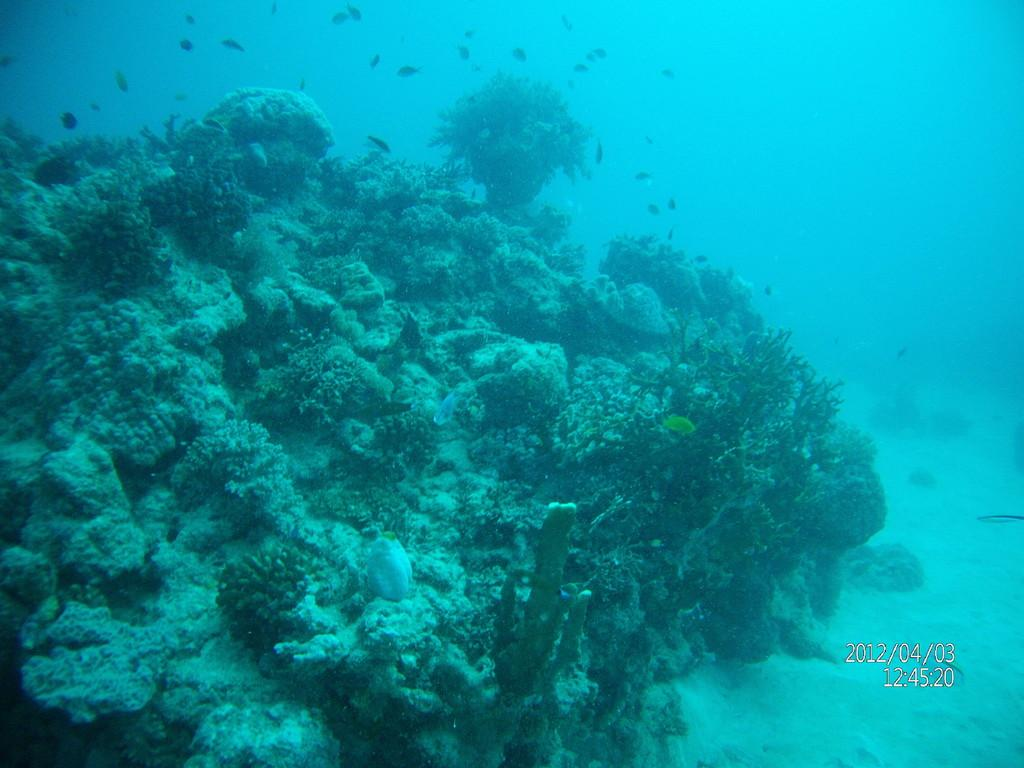What type of plants can be seen in the image? There are underwater plants in the image. What other living organisms are present in the water? There are fishes in the water in the image. Can you tell me the date and time displayed in the image? The date and time are displayed on the right side of the image. What type of ear is visible on the fish in the image? There are no ears visible on the fish in the image, as fish do not have ears like humans. What type of operation is being performed on the underwater plants in the image? There is no operation being performed on the underwater plants in the image; they are simply growing in their natural environment. 